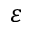Convert formula to latex. <formula><loc_0><loc_0><loc_500><loc_500>\varepsilon</formula> 